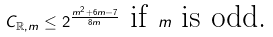Convert formula to latex. <formula><loc_0><loc_0><loc_500><loc_500>C _ { \mathbb { R } , m } \leq 2 ^ { \frac { m ^ { 2 } + 6 m - 7 } { 8 m } } \text { if } m \text { is odd.}</formula> 